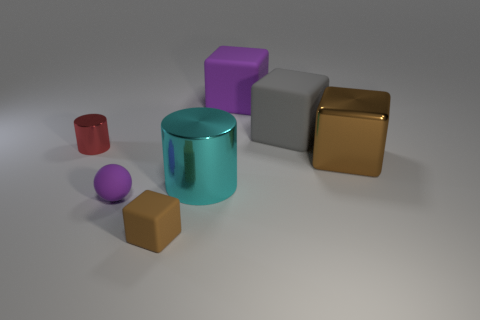Subtract all yellow cylinders. How many brown blocks are left? 2 Subtract all small matte blocks. How many blocks are left? 3 Add 2 large cyan cylinders. How many objects exist? 9 Subtract 2 cubes. How many cubes are left? 2 Subtract all gray cubes. How many cubes are left? 3 Subtract all cylinders. How many objects are left? 5 Subtract all big red cubes. Subtract all large cyan cylinders. How many objects are left? 6 Add 7 large metallic blocks. How many large metallic blocks are left? 8 Add 6 cyan metal things. How many cyan metal things exist? 7 Subtract 0 brown cylinders. How many objects are left? 7 